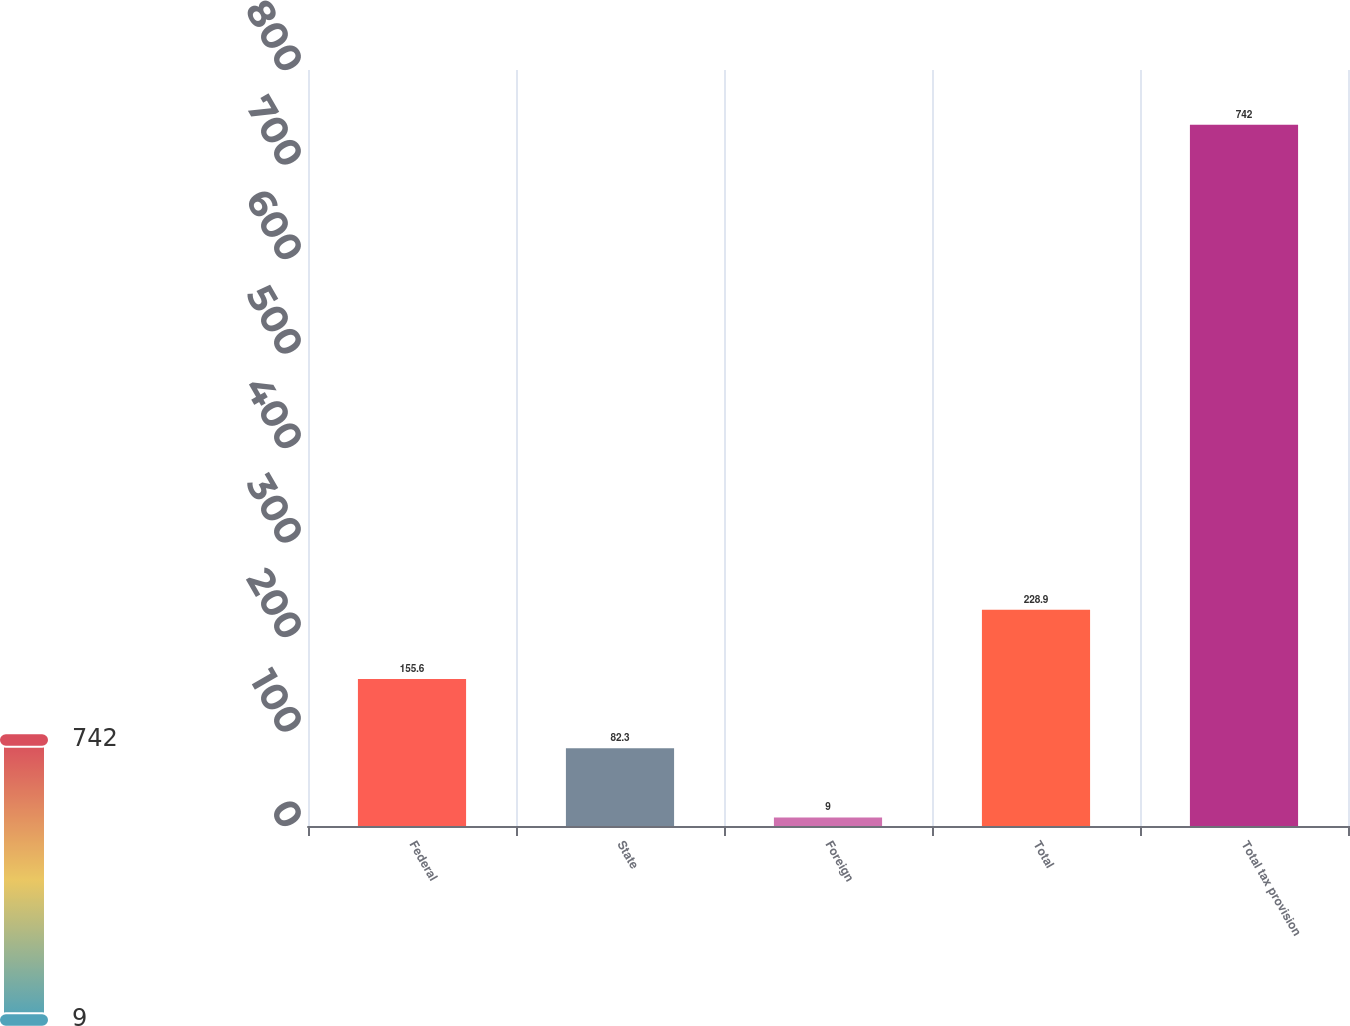<chart> <loc_0><loc_0><loc_500><loc_500><bar_chart><fcel>Federal<fcel>State<fcel>Foreign<fcel>Total<fcel>Total tax provision<nl><fcel>155.6<fcel>82.3<fcel>9<fcel>228.9<fcel>742<nl></chart> 